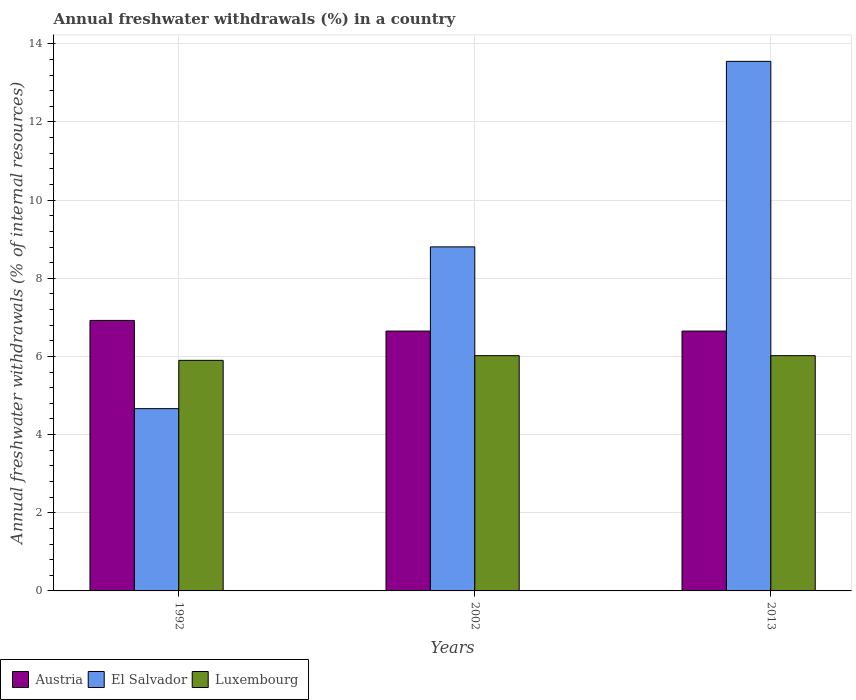How many different coloured bars are there?
Your answer should be compact. 3. What is the label of the 3rd group of bars from the left?
Your answer should be compact. 2013. In how many cases, is the number of bars for a given year not equal to the number of legend labels?
Provide a succinct answer. 0. What is the percentage of annual freshwater withdrawals in Austria in 1992?
Offer a terse response. 6.92. Across all years, what is the maximum percentage of annual freshwater withdrawals in Austria?
Ensure brevity in your answer.  6.92. Across all years, what is the minimum percentage of annual freshwater withdrawals in El Salvador?
Provide a succinct answer. 4.66. In which year was the percentage of annual freshwater withdrawals in El Salvador maximum?
Keep it short and to the point. 2013. In which year was the percentage of annual freshwater withdrawals in El Salvador minimum?
Provide a short and direct response. 1992. What is the total percentage of annual freshwater withdrawals in El Salvador in the graph?
Keep it short and to the point. 27.02. What is the difference between the percentage of annual freshwater withdrawals in Luxembourg in 2002 and the percentage of annual freshwater withdrawals in Austria in 2013?
Make the answer very short. -0.63. What is the average percentage of annual freshwater withdrawals in El Salvador per year?
Keep it short and to the point. 9.01. In the year 2002, what is the difference between the percentage of annual freshwater withdrawals in El Salvador and percentage of annual freshwater withdrawals in Austria?
Keep it short and to the point. 2.15. In how many years, is the percentage of annual freshwater withdrawals in Luxembourg greater than 5.6 %?
Ensure brevity in your answer.  3. What is the ratio of the percentage of annual freshwater withdrawals in El Salvador in 2002 to that in 2013?
Offer a very short reply. 0.65. What is the difference between the highest and the second highest percentage of annual freshwater withdrawals in El Salvador?
Give a very brief answer. 4.75. What is the difference between the highest and the lowest percentage of annual freshwater withdrawals in El Salvador?
Make the answer very short. 8.89. In how many years, is the percentage of annual freshwater withdrawals in Austria greater than the average percentage of annual freshwater withdrawals in Austria taken over all years?
Offer a terse response. 1. Is the sum of the percentage of annual freshwater withdrawals in El Salvador in 1992 and 2013 greater than the maximum percentage of annual freshwater withdrawals in Luxembourg across all years?
Offer a terse response. Yes. What does the 2nd bar from the right in 2013 represents?
Keep it short and to the point. El Salvador. Is it the case that in every year, the sum of the percentage of annual freshwater withdrawals in Luxembourg and percentage of annual freshwater withdrawals in El Salvador is greater than the percentage of annual freshwater withdrawals in Austria?
Offer a terse response. Yes. How many years are there in the graph?
Your answer should be very brief. 3. Where does the legend appear in the graph?
Give a very brief answer. Bottom left. How many legend labels are there?
Provide a short and direct response. 3. How are the legend labels stacked?
Make the answer very short. Horizontal. What is the title of the graph?
Your response must be concise. Annual freshwater withdrawals (%) in a country. Does "Armenia" appear as one of the legend labels in the graph?
Ensure brevity in your answer.  No. What is the label or title of the X-axis?
Make the answer very short. Years. What is the label or title of the Y-axis?
Offer a very short reply. Annual freshwater withdrawals (% of internal resources). What is the Annual freshwater withdrawals (% of internal resources) in Austria in 1992?
Provide a short and direct response. 6.92. What is the Annual freshwater withdrawals (% of internal resources) in El Salvador in 1992?
Provide a succinct answer. 4.66. What is the Annual freshwater withdrawals (% of internal resources) of Luxembourg in 1992?
Ensure brevity in your answer.  5.9. What is the Annual freshwater withdrawals (% of internal resources) in Austria in 2002?
Make the answer very short. 6.65. What is the Annual freshwater withdrawals (% of internal resources) of El Salvador in 2002?
Give a very brief answer. 8.8. What is the Annual freshwater withdrawals (% of internal resources) in Luxembourg in 2002?
Make the answer very short. 6.02. What is the Annual freshwater withdrawals (% of internal resources) in Austria in 2013?
Your response must be concise. 6.65. What is the Annual freshwater withdrawals (% of internal resources) in El Salvador in 2013?
Make the answer very short. 13.55. What is the Annual freshwater withdrawals (% of internal resources) in Luxembourg in 2013?
Make the answer very short. 6.02. Across all years, what is the maximum Annual freshwater withdrawals (% of internal resources) of Austria?
Your answer should be very brief. 6.92. Across all years, what is the maximum Annual freshwater withdrawals (% of internal resources) of El Salvador?
Provide a succinct answer. 13.55. Across all years, what is the maximum Annual freshwater withdrawals (% of internal resources) in Luxembourg?
Offer a very short reply. 6.02. Across all years, what is the minimum Annual freshwater withdrawals (% of internal resources) of Austria?
Offer a terse response. 6.65. Across all years, what is the minimum Annual freshwater withdrawals (% of internal resources) in El Salvador?
Your answer should be compact. 4.66. Across all years, what is the minimum Annual freshwater withdrawals (% of internal resources) in Luxembourg?
Your response must be concise. 5.9. What is the total Annual freshwater withdrawals (% of internal resources) in Austria in the graph?
Make the answer very short. 20.22. What is the total Annual freshwater withdrawals (% of internal resources) in El Salvador in the graph?
Ensure brevity in your answer.  27.02. What is the total Annual freshwater withdrawals (% of internal resources) in Luxembourg in the graph?
Keep it short and to the point. 17.94. What is the difference between the Annual freshwater withdrawals (% of internal resources) of Austria in 1992 and that in 2002?
Keep it short and to the point. 0.27. What is the difference between the Annual freshwater withdrawals (% of internal resources) of El Salvador in 1992 and that in 2002?
Your answer should be very brief. -4.14. What is the difference between the Annual freshwater withdrawals (% of internal resources) in Luxembourg in 1992 and that in 2002?
Your answer should be very brief. -0.12. What is the difference between the Annual freshwater withdrawals (% of internal resources) in Austria in 1992 and that in 2013?
Your answer should be compact. 0.27. What is the difference between the Annual freshwater withdrawals (% of internal resources) of El Salvador in 1992 and that in 2013?
Provide a succinct answer. -8.89. What is the difference between the Annual freshwater withdrawals (% of internal resources) of Luxembourg in 1992 and that in 2013?
Make the answer very short. -0.12. What is the difference between the Annual freshwater withdrawals (% of internal resources) of Austria in 2002 and that in 2013?
Offer a terse response. 0. What is the difference between the Annual freshwater withdrawals (% of internal resources) of El Salvador in 2002 and that in 2013?
Provide a succinct answer. -4.75. What is the difference between the Annual freshwater withdrawals (% of internal resources) of Luxembourg in 2002 and that in 2013?
Your response must be concise. 0. What is the difference between the Annual freshwater withdrawals (% of internal resources) of Austria in 1992 and the Annual freshwater withdrawals (% of internal resources) of El Salvador in 2002?
Make the answer very short. -1.88. What is the difference between the Annual freshwater withdrawals (% of internal resources) of Austria in 1992 and the Annual freshwater withdrawals (% of internal resources) of Luxembourg in 2002?
Offer a very short reply. 0.9. What is the difference between the Annual freshwater withdrawals (% of internal resources) in El Salvador in 1992 and the Annual freshwater withdrawals (% of internal resources) in Luxembourg in 2002?
Your answer should be very brief. -1.36. What is the difference between the Annual freshwater withdrawals (% of internal resources) of Austria in 1992 and the Annual freshwater withdrawals (% of internal resources) of El Salvador in 2013?
Make the answer very short. -6.63. What is the difference between the Annual freshwater withdrawals (% of internal resources) of Austria in 1992 and the Annual freshwater withdrawals (% of internal resources) of Luxembourg in 2013?
Offer a very short reply. 0.9. What is the difference between the Annual freshwater withdrawals (% of internal resources) of El Salvador in 1992 and the Annual freshwater withdrawals (% of internal resources) of Luxembourg in 2013?
Your answer should be compact. -1.36. What is the difference between the Annual freshwater withdrawals (% of internal resources) in Austria in 2002 and the Annual freshwater withdrawals (% of internal resources) in El Salvador in 2013?
Your answer should be compact. -6.9. What is the difference between the Annual freshwater withdrawals (% of internal resources) in Austria in 2002 and the Annual freshwater withdrawals (% of internal resources) in Luxembourg in 2013?
Your answer should be very brief. 0.63. What is the difference between the Annual freshwater withdrawals (% of internal resources) of El Salvador in 2002 and the Annual freshwater withdrawals (% of internal resources) of Luxembourg in 2013?
Your response must be concise. 2.78. What is the average Annual freshwater withdrawals (% of internal resources) in Austria per year?
Offer a terse response. 6.74. What is the average Annual freshwater withdrawals (% of internal resources) of El Salvador per year?
Ensure brevity in your answer.  9.01. What is the average Annual freshwater withdrawals (% of internal resources) of Luxembourg per year?
Your answer should be compact. 5.98. In the year 1992, what is the difference between the Annual freshwater withdrawals (% of internal resources) of Austria and Annual freshwater withdrawals (% of internal resources) of El Salvador?
Give a very brief answer. 2.26. In the year 1992, what is the difference between the Annual freshwater withdrawals (% of internal resources) in Austria and Annual freshwater withdrawals (% of internal resources) in Luxembourg?
Ensure brevity in your answer.  1.02. In the year 1992, what is the difference between the Annual freshwater withdrawals (% of internal resources) in El Salvador and Annual freshwater withdrawals (% of internal resources) in Luxembourg?
Offer a terse response. -1.24. In the year 2002, what is the difference between the Annual freshwater withdrawals (% of internal resources) in Austria and Annual freshwater withdrawals (% of internal resources) in El Salvador?
Give a very brief answer. -2.15. In the year 2002, what is the difference between the Annual freshwater withdrawals (% of internal resources) of Austria and Annual freshwater withdrawals (% of internal resources) of Luxembourg?
Your answer should be compact. 0.63. In the year 2002, what is the difference between the Annual freshwater withdrawals (% of internal resources) of El Salvador and Annual freshwater withdrawals (% of internal resources) of Luxembourg?
Make the answer very short. 2.78. In the year 2013, what is the difference between the Annual freshwater withdrawals (% of internal resources) in Austria and Annual freshwater withdrawals (% of internal resources) in El Salvador?
Ensure brevity in your answer.  -6.9. In the year 2013, what is the difference between the Annual freshwater withdrawals (% of internal resources) of Austria and Annual freshwater withdrawals (% of internal resources) of Luxembourg?
Keep it short and to the point. 0.63. In the year 2013, what is the difference between the Annual freshwater withdrawals (% of internal resources) in El Salvador and Annual freshwater withdrawals (% of internal resources) in Luxembourg?
Give a very brief answer. 7.53. What is the ratio of the Annual freshwater withdrawals (% of internal resources) of Austria in 1992 to that in 2002?
Offer a very short reply. 1.04. What is the ratio of the Annual freshwater withdrawals (% of internal resources) in El Salvador in 1992 to that in 2002?
Provide a succinct answer. 0.53. What is the ratio of the Annual freshwater withdrawals (% of internal resources) of Luxembourg in 1992 to that in 2002?
Give a very brief answer. 0.98. What is the ratio of the Annual freshwater withdrawals (% of internal resources) of Austria in 1992 to that in 2013?
Keep it short and to the point. 1.04. What is the ratio of the Annual freshwater withdrawals (% of internal resources) in El Salvador in 1992 to that in 2013?
Provide a succinct answer. 0.34. What is the ratio of the Annual freshwater withdrawals (% of internal resources) in Luxembourg in 1992 to that in 2013?
Give a very brief answer. 0.98. What is the ratio of the Annual freshwater withdrawals (% of internal resources) in El Salvador in 2002 to that in 2013?
Provide a succinct answer. 0.65. What is the difference between the highest and the second highest Annual freshwater withdrawals (% of internal resources) in Austria?
Your answer should be very brief. 0.27. What is the difference between the highest and the second highest Annual freshwater withdrawals (% of internal resources) in El Salvador?
Your response must be concise. 4.75. What is the difference between the highest and the lowest Annual freshwater withdrawals (% of internal resources) in Austria?
Keep it short and to the point. 0.27. What is the difference between the highest and the lowest Annual freshwater withdrawals (% of internal resources) of El Salvador?
Your answer should be compact. 8.89. What is the difference between the highest and the lowest Annual freshwater withdrawals (% of internal resources) in Luxembourg?
Keep it short and to the point. 0.12. 